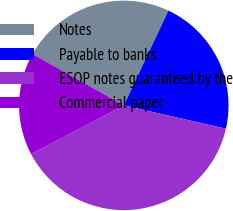Convert chart. <chart><loc_0><loc_0><loc_500><loc_500><pie_chart><fcel>Notes<fcel>Payable to banks<fcel>ESOP notes guaranteed by the<fcel>Commercial paper<nl><fcel>23.86%<fcel>21.57%<fcel>38.73%<fcel>15.85%<nl></chart> 